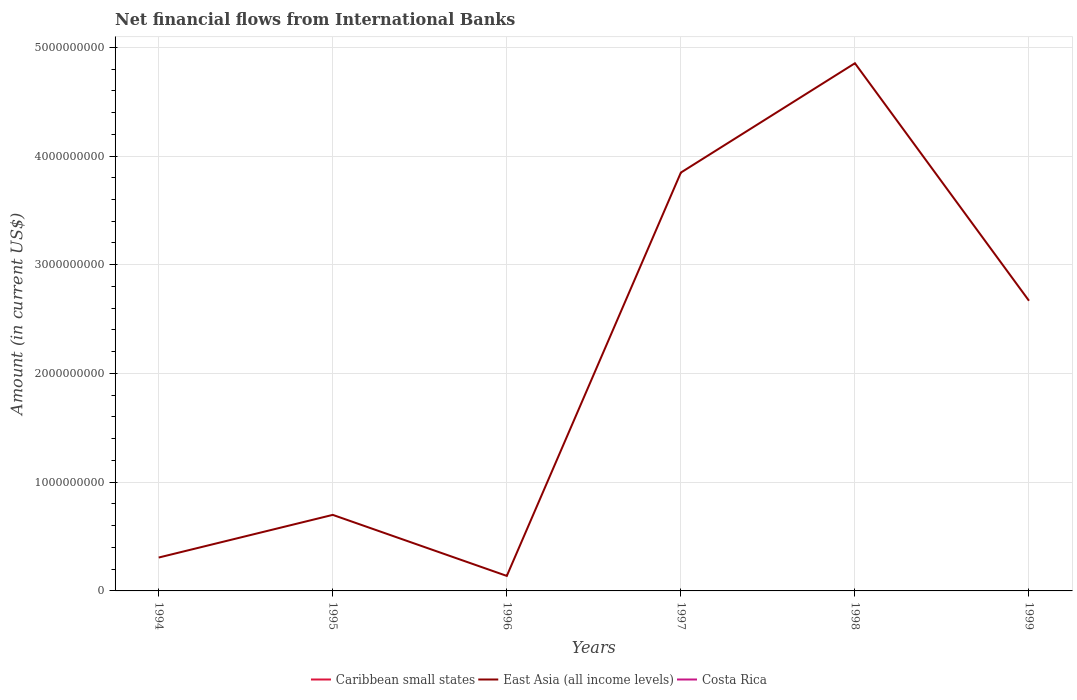How many different coloured lines are there?
Make the answer very short. 1. Is the number of lines equal to the number of legend labels?
Provide a short and direct response. No. Across all years, what is the maximum net financial aid flows in East Asia (all income levels)?
Provide a succinct answer. 1.38e+08. What is the total net financial aid flows in East Asia (all income levels) in the graph?
Provide a succinct answer. -2.53e+09. What is the difference between the highest and the second highest net financial aid flows in East Asia (all income levels)?
Offer a very short reply. 4.72e+09. What is the difference between the highest and the lowest net financial aid flows in Costa Rica?
Offer a very short reply. 0. Is the net financial aid flows in Caribbean small states strictly greater than the net financial aid flows in East Asia (all income levels) over the years?
Your answer should be very brief. Yes. Does the graph contain any zero values?
Make the answer very short. Yes. Where does the legend appear in the graph?
Keep it short and to the point. Bottom center. How many legend labels are there?
Give a very brief answer. 3. How are the legend labels stacked?
Make the answer very short. Horizontal. What is the title of the graph?
Give a very brief answer. Net financial flows from International Banks. What is the label or title of the Y-axis?
Your answer should be compact. Amount (in current US$). What is the Amount (in current US$) in East Asia (all income levels) in 1994?
Offer a very short reply. 3.07e+08. What is the Amount (in current US$) in Caribbean small states in 1995?
Make the answer very short. 0. What is the Amount (in current US$) of East Asia (all income levels) in 1995?
Provide a succinct answer. 6.99e+08. What is the Amount (in current US$) in Caribbean small states in 1996?
Offer a very short reply. 0. What is the Amount (in current US$) in East Asia (all income levels) in 1996?
Your answer should be compact. 1.38e+08. What is the Amount (in current US$) in Costa Rica in 1996?
Make the answer very short. 0. What is the Amount (in current US$) in East Asia (all income levels) in 1997?
Provide a succinct answer. 3.85e+09. What is the Amount (in current US$) in Costa Rica in 1997?
Ensure brevity in your answer.  0. What is the Amount (in current US$) of East Asia (all income levels) in 1998?
Offer a terse response. 4.85e+09. What is the Amount (in current US$) in Costa Rica in 1998?
Offer a very short reply. 0. What is the Amount (in current US$) of East Asia (all income levels) in 1999?
Provide a short and direct response. 2.67e+09. What is the Amount (in current US$) in Costa Rica in 1999?
Ensure brevity in your answer.  0. Across all years, what is the maximum Amount (in current US$) in East Asia (all income levels)?
Provide a succinct answer. 4.85e+09. Across all years, what is the minimum Amount (in current US$) in East Asia (all income levels)?
Your answer should be compact. 1.38e+08. What is the total Amount (in current US$) in Caribbean small states in the graph?
Offer a terse response. 0. What is the total Amount (in current US$) of East Asia (all income levels) in the graph?
Give a very brief answer. 1.25e+1. What is the difference between the Amount (in current US$) in East Asia (all income levels) in 1994 and that in 1995?
Keep it short and to the point. -3.92e+08. What is the difference between the Amount (in current US$) in East Asia (all income levels) in 1994 and that in 1996?
Provide a succinct answer. 1.69e+08. What is the difference between the Amount (in current US$) of East Asia (all income levels) in 1994 and that in 1997?
Provide a succinct answer. -3.54e+09. What is the difference between the Amount (in current US$) of East Asia (all income levels) in 1994 and that in 1998?
Provide a short and direct response. -4.55e+09. What is the difference between the Amount (in current US$) in East Asia (all income levels) in 1994 and that in 1999?
Provide a short and direct response. -2.36e+09. What is the difference between the Amount (in current US$) in East Asia (all income levels) in 1995 and that in 1996?
Your answer should be compact. 5.61e+08. What is the difference between the Amount (in current US$) in East Asia (all income levels) in 1995 and that in 1997?
Your answer should be very brief. -3.15e+09. What is the difference between the Amount (in current US$) of East Asia (all income levels) in 1995 and that in 1998?
Provide a short and direct response. -4.15e+09. What is the difference between the Amount (in current US$) of East Asia (all income levels) in 1995 and that in 1999?
Your answer should be compact. -1.97e+09. What is the difference between the Amount (in current US$) of East Asia (all income levels) in 1996 and that in 1997?
Ensure brevity in your answer.  -3.71e+09. What is the difference between the Amount (in current US$) in East Asia (all income levels) in 1996 and that in 1998?
Your response must be concise. -4.72e+09. What is the difference between the Amount (in current US$) of East Asia (all income levels) in 1996 and that in 1999?
Give a very brief answer. -2.53e+09. What is the difference between the Amount (in current US$) in East Asia (all income levels) in 1997 and that in 1998?
Your response must be concise. -1.01e+09. What is the difference between the Amount (in current US$) of East Asia (all income levels) in 1997 and that in 1999?
Your answer should be compact. 1.18e+09. What is the difference between the Amount (in current US$) in East Asia (all income levels) in 1998 and that in 1999?
Your answer should be compact. 2.18e+09. What is the average Amount (in current US$) of East Asia (all income levels) per year?
Provide a succinct answer. 2.09e+09. What is the average Amount (in current US$) of Costa Rica per year?
Your response must be concise. 0. What is the ratio of the Amount (in current US$) in East Asia (all income levels) in 1994 to that in 1995?
Offer a terse response. 0.44. What is the ratio of the Amount (in current US$) in East Asia (all income levels) in 1994 to that in 1996?
Give a very brief answer. 2.22. What is the ratio of the Amount (in current US$) in East Asia (all income levels) in 1994 to that in 1997?
Provide a short and direct response. 0.08. What is the ratio of the Amount (in current US$) of East Asia (all income levels) in 1994 to that in 1998?
Your answer should be compact. 0.06. What is the ratio of the Amount (in current US$) in East Asia (all income levels) in 1994 to that in 1999?
Keep it short and to the point. 0.12. What is the ratio of the Amount (in current US$) of East Asia (all income levels) in 1995 to that in 1996?
Keep it short and to the point. 5.07. What is the ratio of the Amount (in current US$) in East Asia (all income levels) in 1995 to that in 1997?
Ensure brevity in your answer.  0.18. What is the ratio of the Amount (in current US$) in East Asia (all income levels) in 1995 to that in 1998?
Give a very brief answer. 0.14. What is the ratio of the Amount (in current US$) of East Asia (all income levels) in 1995 to that in 1999?
Offer a very short reply. 0.26. What is the ratio of the Amount (in current US$) of East Asia (all income levels) in 1996 to that in 1997?
Offer a very short reply. 0.04. What is the ratio of the Amount (in current US$) of East Asia (all income levels) in 1996 to that in 1998?
Offer a very short reply. 0.03. What is the ratio of the Amount (in current US$) of East Asia (all income levels) in 1996 to that in 1999?
Keep it short and to the point. 0.05. What is the ratio of the Amount (in current US$) in East Asia (all income levels) in 1997 to that in 1998?
Give a very brief answer. 0.79. What is the ratio of the Amount (in current US$) in East Asia (all income levels) in 1997 to that in 1999?
Offer a terse response. 1.44. What is the ratio of the Amount (in current US$) of East Asia (all income levels) in 1998 to that in 1999?
Provide a short and direct response. 1.82. What is the difference between the highest and the second highest Amount (in current US$) in East Asia (all income levels)?
Your answer should be compact. 1.01e+09. What is the difference between the highest and the lowest Amount (in current US$) of East Asia (all income levels)?
Give a very brief answer. 4.72e+09. 